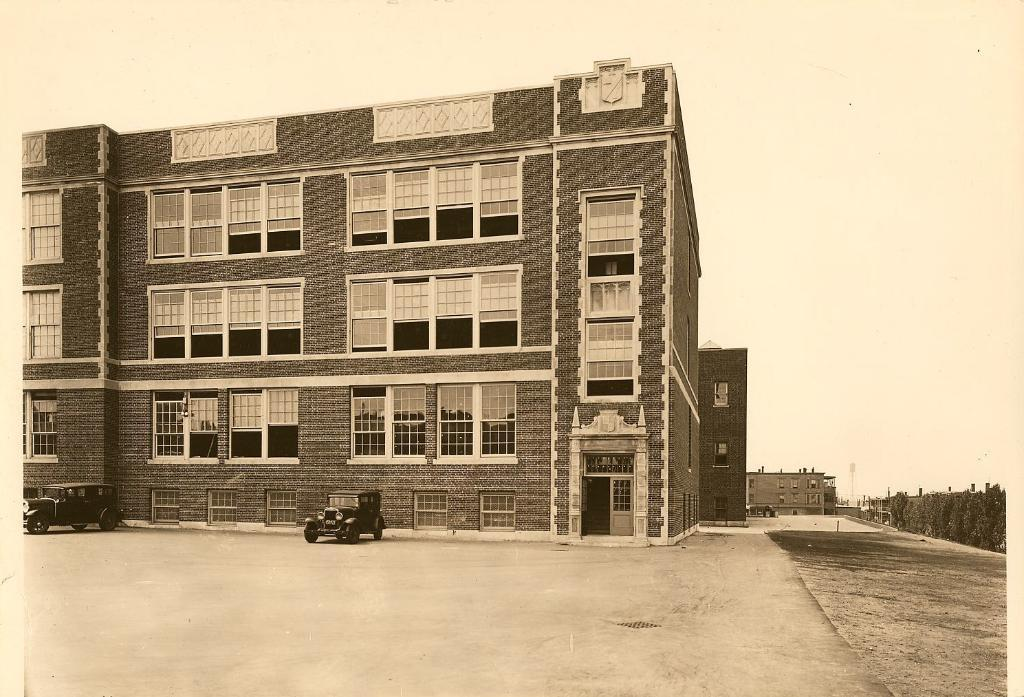What is located in the center of the image? There are buildings in the center of the image. What can be seen at the bottom of the image? Vehicles are visible at the bottom of the image. What is on the right side of the image? There is a wall on the right side of the image. What is visible at the top of the image? The sky is visible at the top of the image. How does the wall control the haircut in the image? There is no haircut present in the image, and the wall does not control anything in the image. 